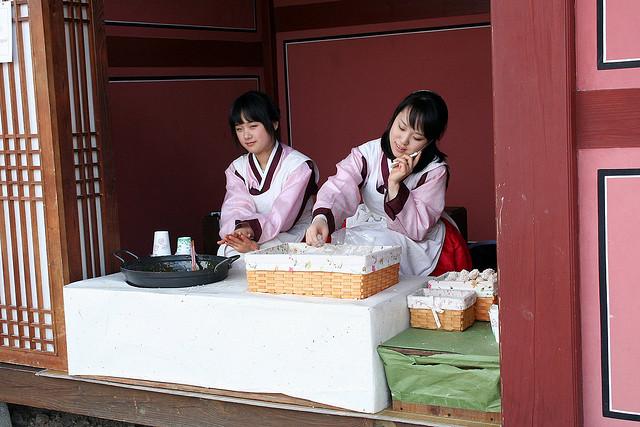Do these ladies have on the same outfit?
Be succinct. Yes. What color is the table?
Write a very short answer. White. What culture are the ladies from?
Keep it brief. Asian. 